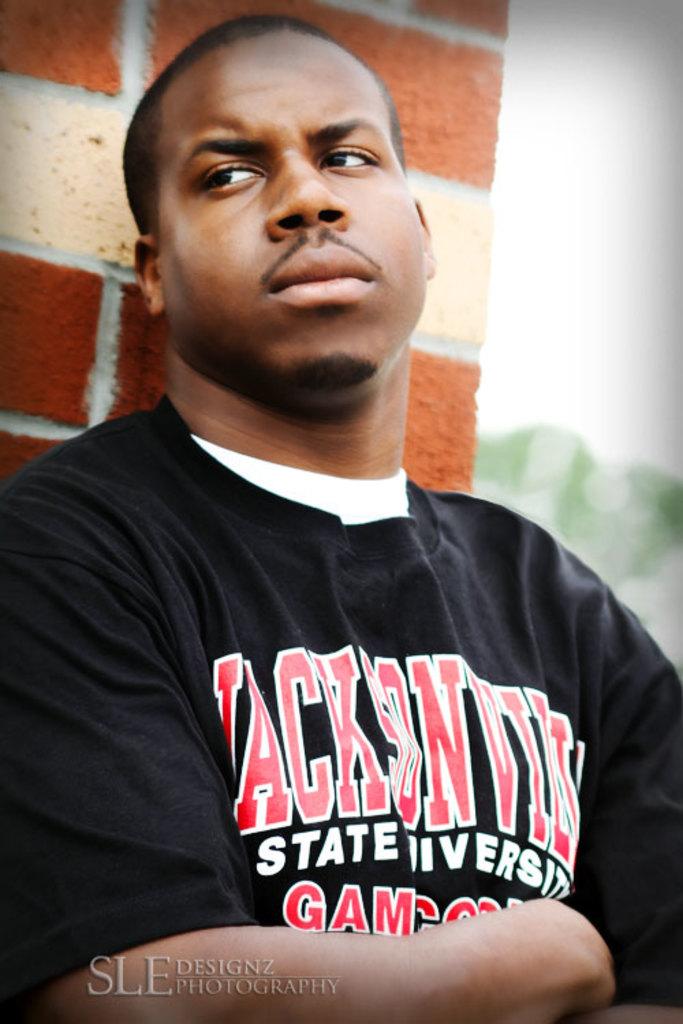What university is the shirt for?
Your response must be concise. Jacksonville state. 